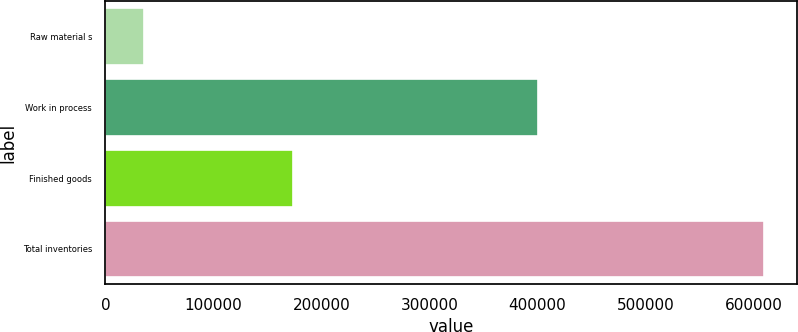Convert chart to OTSL. <chart><loc_0><loc_0><loc_500><loc_500><bar_chart><fcel>Raw material s<fcel>Work in process<fcel>Finished goods<fcel>Total inventories<nl><fcel>35447<fcel>400409<fcel>174030<fcel>609886<nl></chart> 